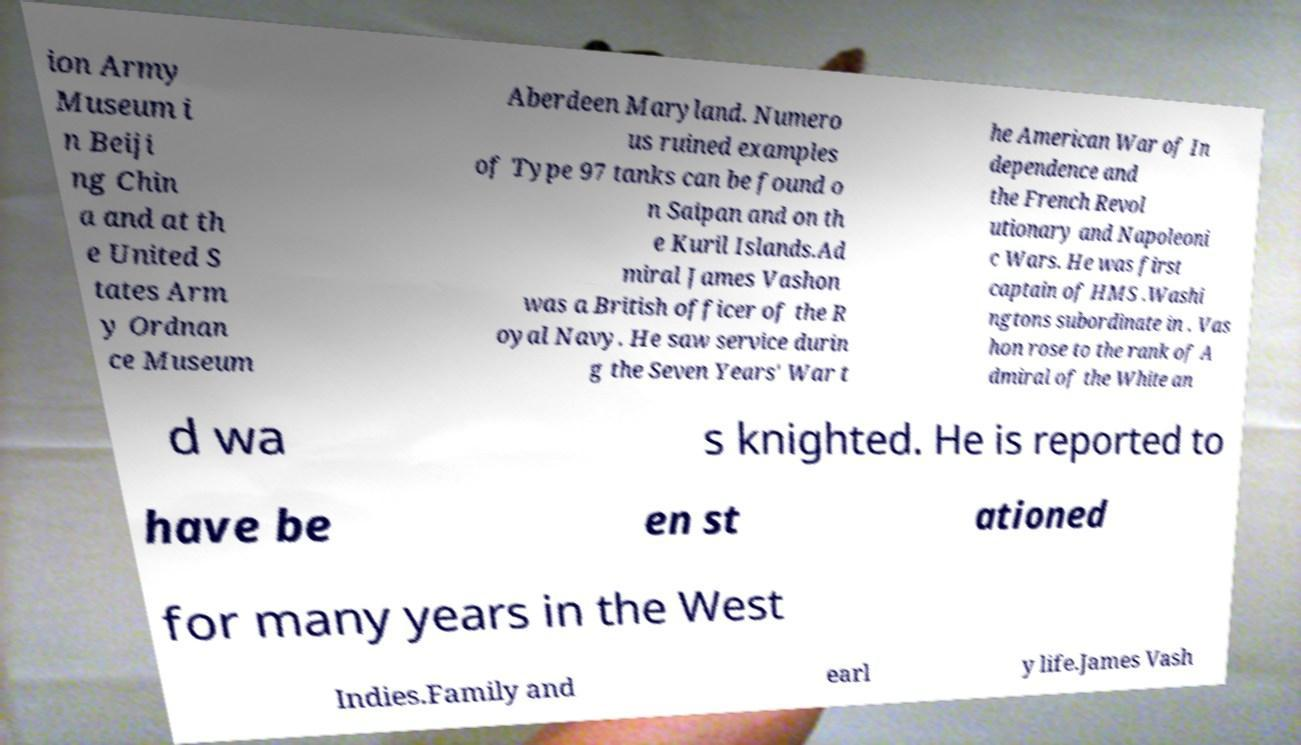For documentation purposes, I need the text within this image transcribed. Could you provide that? ion Army Museum i n Beiji ng Chin a and at th e United S tates Arm y Ordnan ce Museum Aberdeen Maryland. Numero us ruined examples of Type 97 tanks can be found o n Saipan and on th e Kuril Islands.Ad miral James Vashon was a British officer of the R oyal Navy. He saw service durin g the Seven Years' War t he American War of In dependence and the French Revol utionary and Napoleoni c Wars. He was first captain of HMS .Washi ngtons subordinate in . Vas hon rose to the rank of A dmiral of the White an d wa s knighted. He is reported to have be en st ationed for many years in the West Indies.Family and earl y life.James Vash 